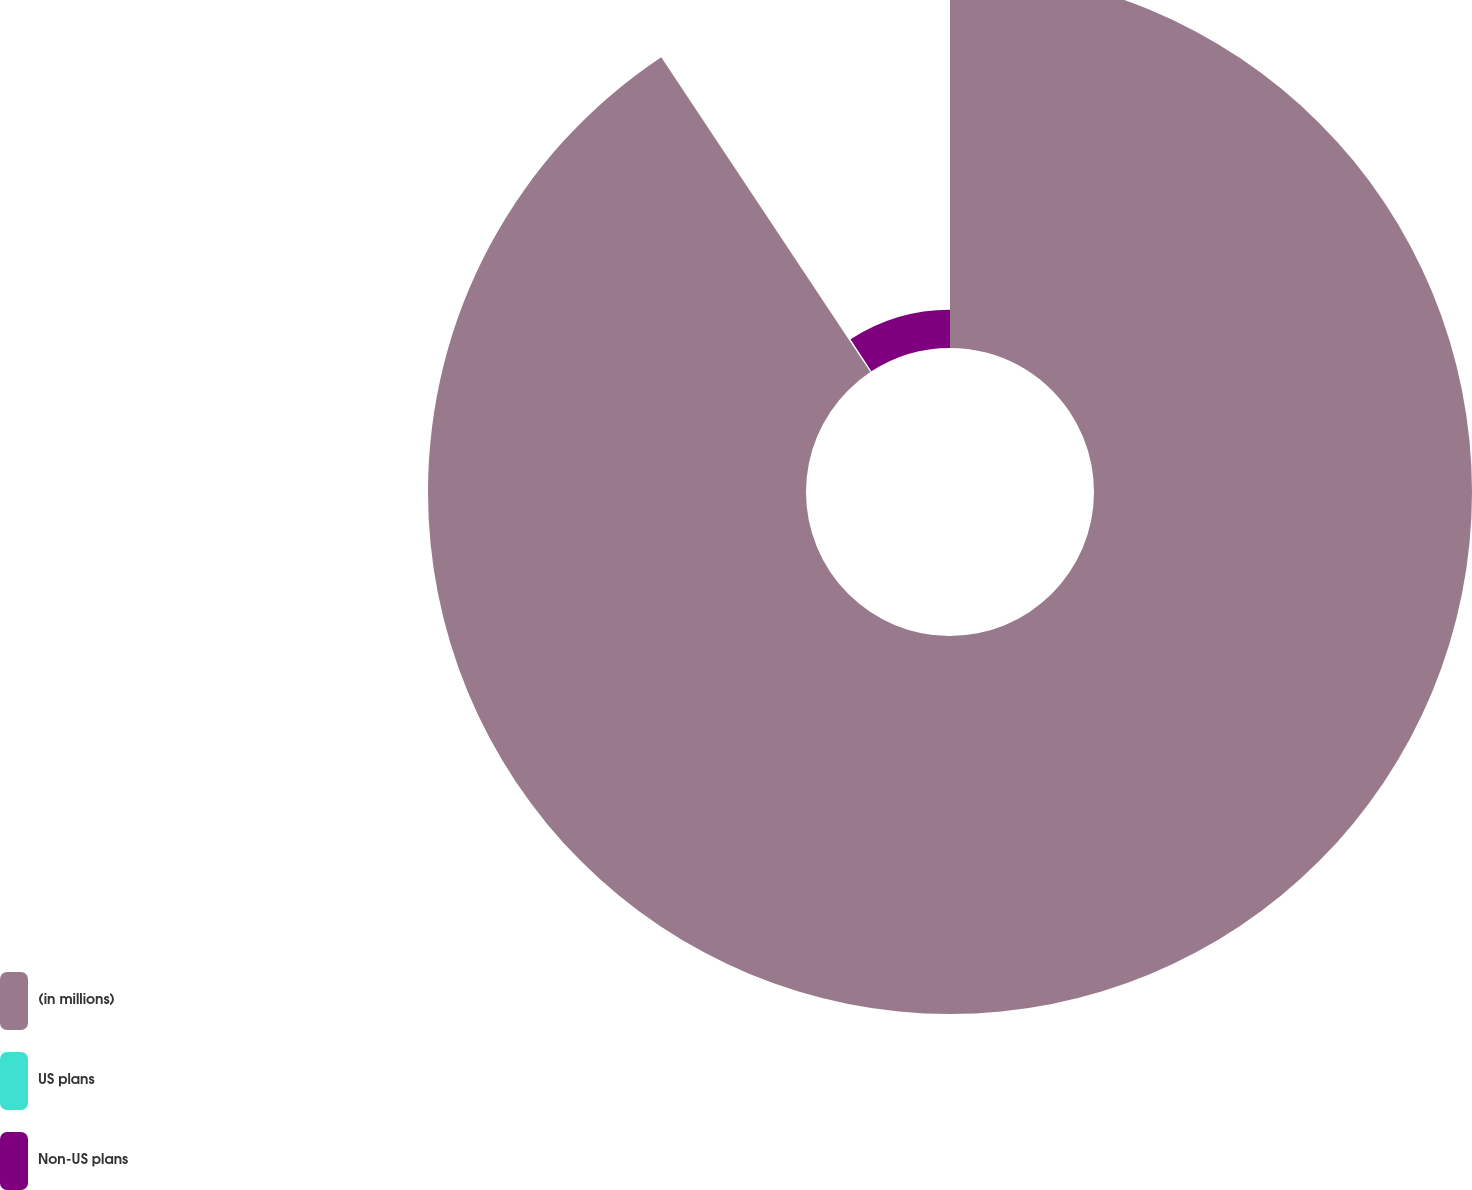Convert chart to OTSL. <chart><loc_0><loc_0><loc_500><loc_500><pie_chart><fcel>(in millions)<fcel>US plans<fcel>Non-US plans<nl><fcel>90.68%<fcel>0.14%<fcel>9.19%<nl></chart> 